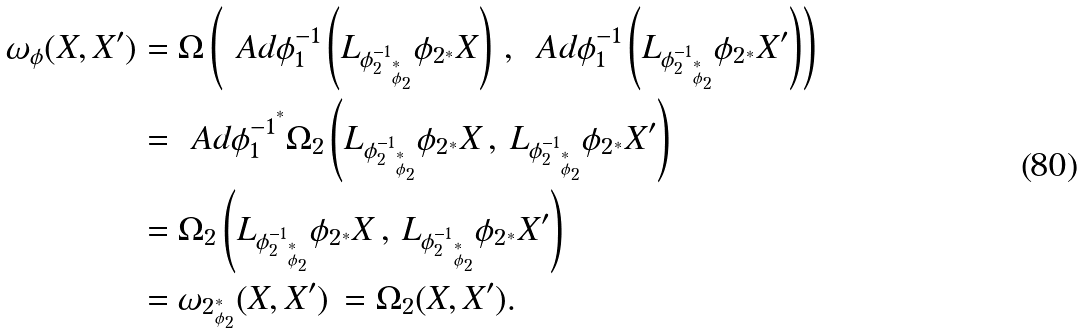<formula> <loc_0><loc_0><loc_500><loc_500>\omega _ { \phi } ( X , X ^ { \prime } ) & = \Omega \left ( \ A d \phi _ { 1 } ^ { - 1 } \left ( L _ { { \phi _ { 2 } ^ { - 1 } } _ { ^ { * } _ { \phi _ { 2 } } } } { \phi _ { 2 } } _ { ^ { * } } X \right ) \, , \, \ A d \phi _ { 1 } ^ { - 1 } \left ( L _ { { \phi _ { 2 } ^ { - 1 } } _ { ^ { * } _ { \phi _ { 2 } } } } { \phi _ { 2 } } _ { ^ { * } } X ^ { \prime } \right ) \right ) \\ & = { \ A d \phi _ { 1 } ^ { - 1 } } ^ { ^ { * } } \Omega _ { 2 } \left ( L _ { { \phi _ { 2 } ^ { - 1 } } _ { ^ { * } _ { \phi _ { 2 } } } } { \phi _ { 2 } } _ { ^ { * } } X \, , \, L _ { { \phi _ { 2 } ^ { - 1 } } _ { ^ { * } _ { \phi _ { 2 } } } } { \phi _ { 2 } } _ { ^ { * } } X ^ { \prime } \right ) \\ & = \Omega _ { 2 } \left ( L _ { { \phi _ { 2 } ^ { - 1 } } _ { ^ { * } _ { \phi _ { 2 } } } } { \phi _ { 2 } } _ { ^ { * } } X \, , \, L _ { { \phi _ { 2 } ^ { - 1 } } _ { ^ { * } _ { \phi _ { 2 } } } } { \phi _ { 2 } } _ { ^ { * } } X ^ { \prime } \right ) \\ & = { \omega _ { 2 } } _ { ^ { * } _ { \phi _ { 2 } } } ( X , X ^ { \prime } ) \, = \Omega _ { 2 } ( X , X ^ { \prime } ) .</formula> 